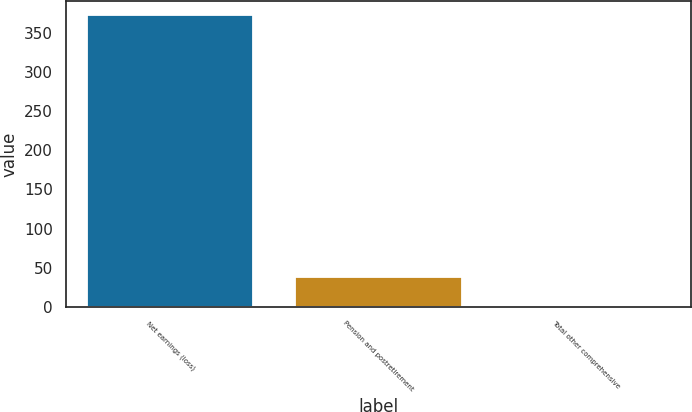Convert chart. <chart><loc_0><loc_0><loc_500><loc_500><bar_chart><fcel>Net earnings (loss)<fcel>Pension and postretirement<fcel>Total other comprehensive<nl><fcel>372<fcel>38.1<fcel>1<nl></chart> 